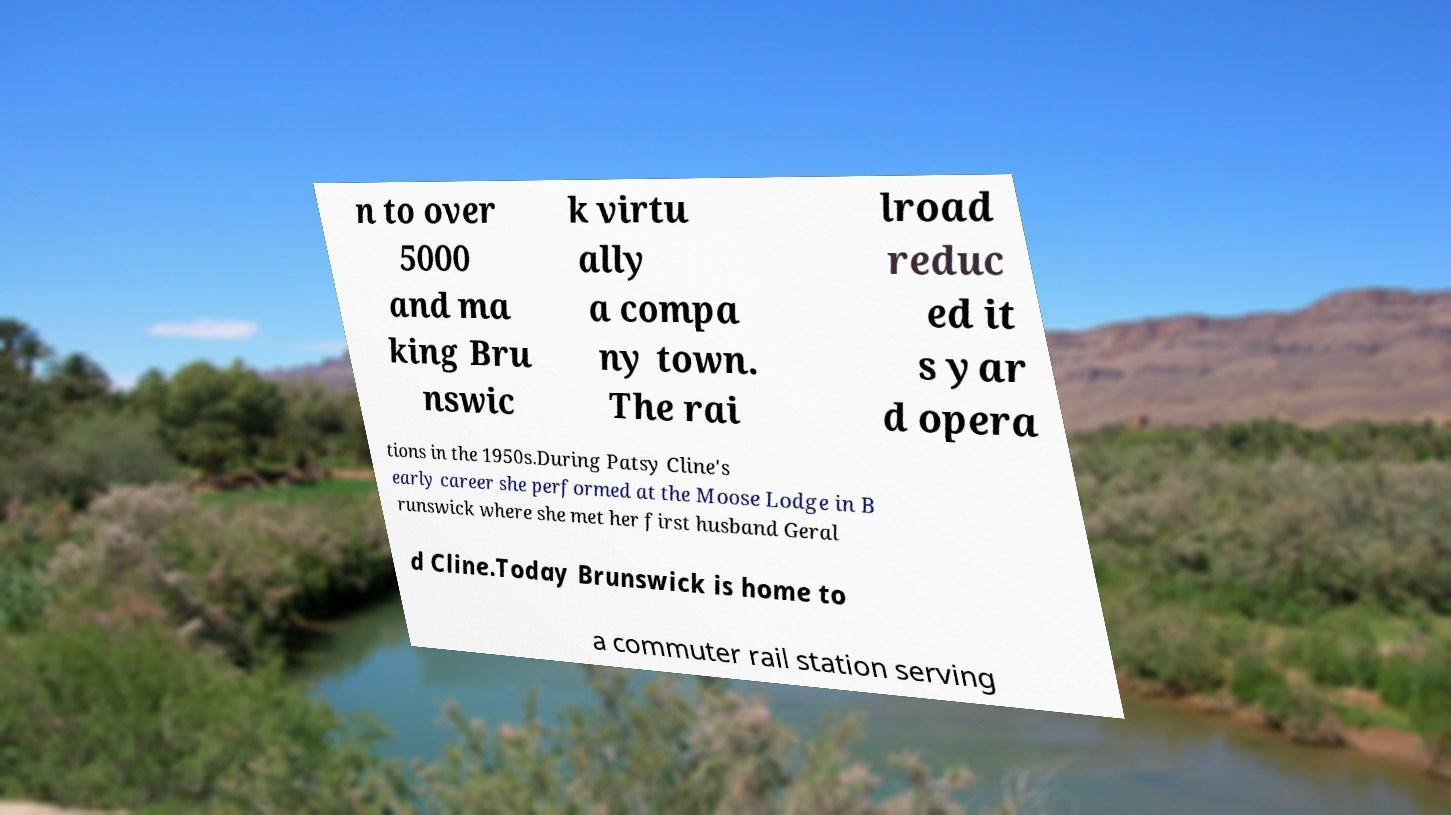Can you accurately transcribe the text from the provided image for me? n to over 5000 and ma king Bru nswic k virtu ally a compa ny town. The rai lroad reduc ed it s yar d opera tions in the 1950s.During Patsy Cline's early career she performed at the Moose Lodge in B runswick where she met her first husband Geral d Cline.Today Brunswick is home to a commuter rail station serving 